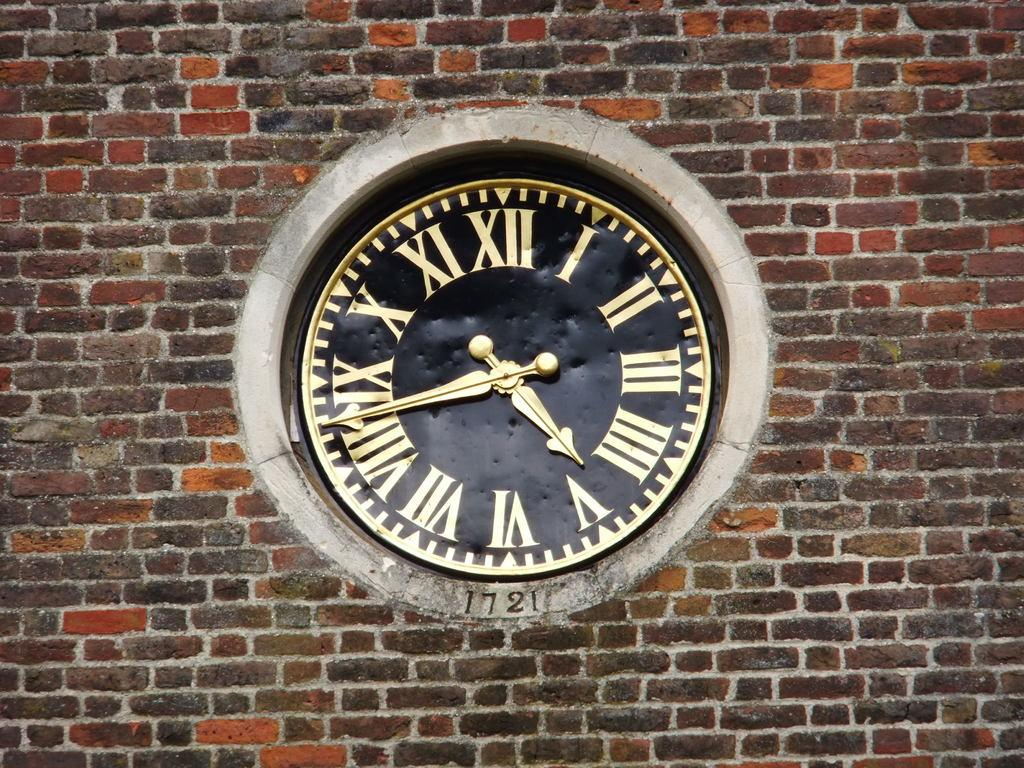Provide a one-sentence caption for the provided image. A clock embedded in a brick wall, made in 1721. 